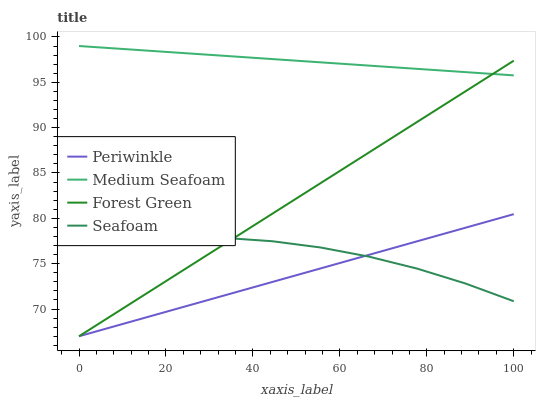Does Periwinkle have the minimum area under the curve?
Answer yes or no. Yes. Does Medium Seafoam have the maximum area under the curve?
Answer yes or no. Yes. Does Medium Seafoam have the minimum area under the curve?
Answer yes or no. No. Does Periwinkle have the maximum area under the curve?
Answer yes or no. No. Is Forest Green the smoothest?
Answer yes or no. Yes. Is Seafoam the roughest?
Answer yes or no. Yes. Is Periwinkle the smoothest?
Answer yes or no. No. Is Periwinkle the roughest?
Answer yes or no. No. Does Forest Green have the lowest value?
Answer yes or no. Yes. Does Medium Seafoam have the lowest value?
Answer yes or no. No. Does Medium Seafoam have the highest value?
Answer yes or no. Yes. Does Periwinkle have the highest value?
Answer yes or no. No. Is Periwinkle less than Medium Seafoam?
Answer yes or no. Yes. Is Medium Seafoam greater than Periwinkle?
Answer yes or no. Yes. Does Forest Green intersect Seafoam?
Answer yes or no. Yes. Is Forest Green less than Seafoam?
Answer yes or no. No. Is Forest Green greater than Seafoam?
Answer yes or no. No. Does Periwinkle intersect Medium Seafoam?
Answer yes or no. No. 